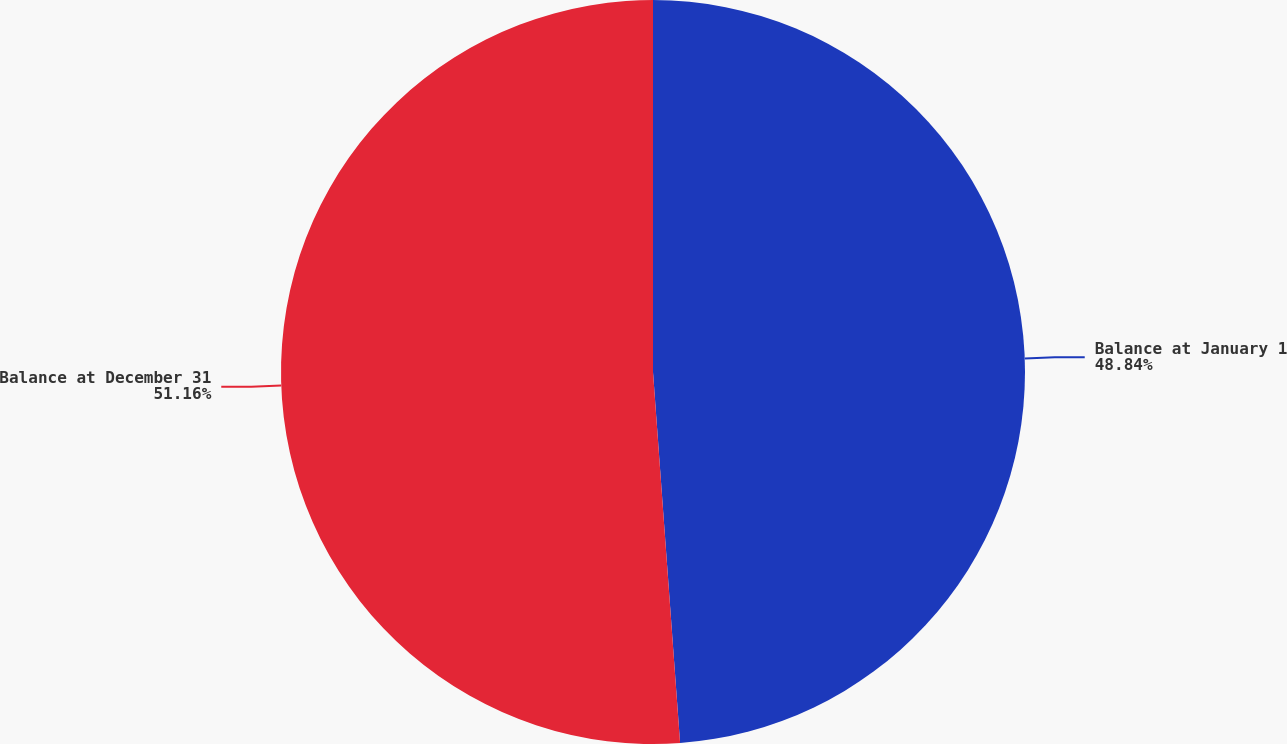Convert chart to OTSL. <chart><loc_0><loc_0><loc_500><loc_500><pie_chart><fcel>Balance at January 1<fcel>Balance at December 31<nl><fcel>48.84%<fcel>51.16%<nl></chart> 